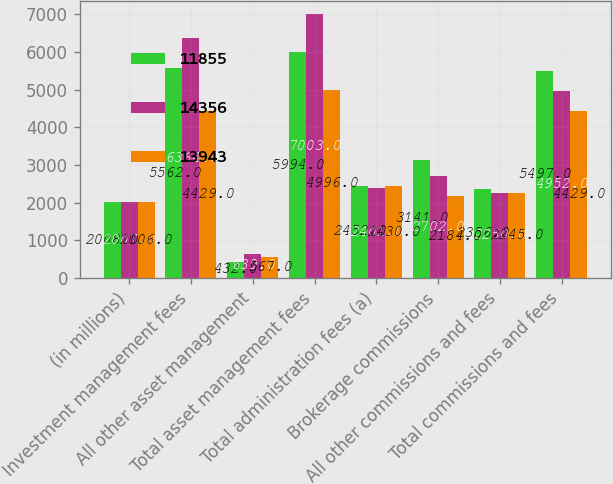Convert chart to OTSL. <chart><loc_0><loc_0><loc_500><loc_500><stacked_bar_chart><ecel><fcel>(in millions)<fcel>Investment management fees<fcel>All other asset management<fcel>Total asset management fees<fcel>Total administration fees (a)<fcel>Brokerage commissions<fcel>All other commissions and fees<fcel>Total commissions and fees<nl><fcel>11855<fcel>2008<fcel>5562<fcel>432<fcel>5994<fcel>2452<fcel>3141<fcel>2356<fcel>5497<nl><fcel>14356<fcel>2007<fcel>6364<fcel>639<fcel>7003<fcel>2401<fcel>2702<fcel>2250<fcel>4952<nl><fcel>13943<fcel>2006<fcel>4429<fcel>567<fcel>4996<fcel>2430<fcel>2184<fcel>2245<fcel>4429<nl></chart> 